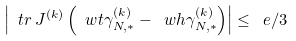<formula> <loc_0><loc_0><loc_500><loc_500>\left | \ t r \, J ^ { ( k ) } \left ( \ w t \gamma ^ { ( k ) } _ { N , * } - \ w h \gamma ^ { ( k ) } _ { N , * } \right ) \right | \leq \ e / 3</formula> 